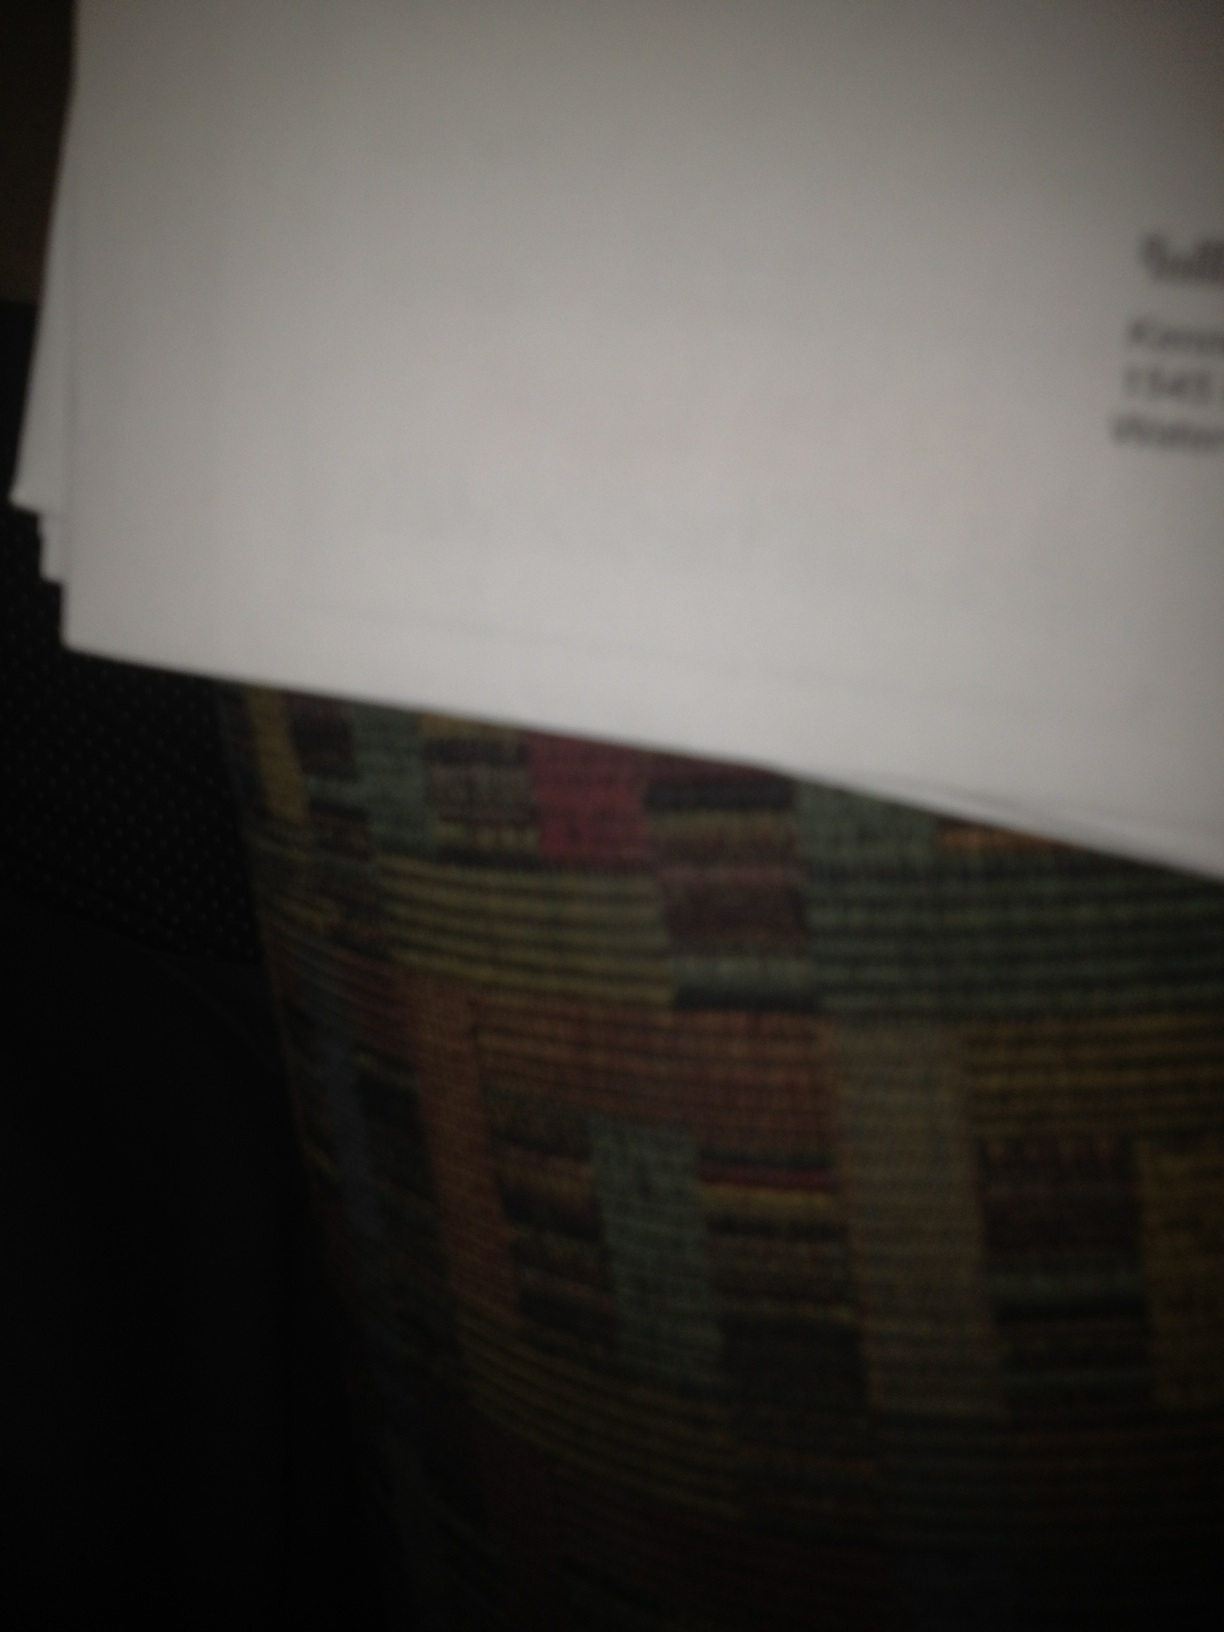Describe the texture or color scheme visible in the image. The document is primarily white, suggesting standard office paper, while the background is a multicolored fabric, likely upholstery with a complex, overlapping square pattern in muted earth tones. Could the color or texture provide any context to the setting or use of the document? The muted colors and pattern of the upholstery might suggest a home or casual business setting, often associated with personal furniture. This context might imply that the document is a part of personal or informal business dealings, rather than a formal corporate environment. 